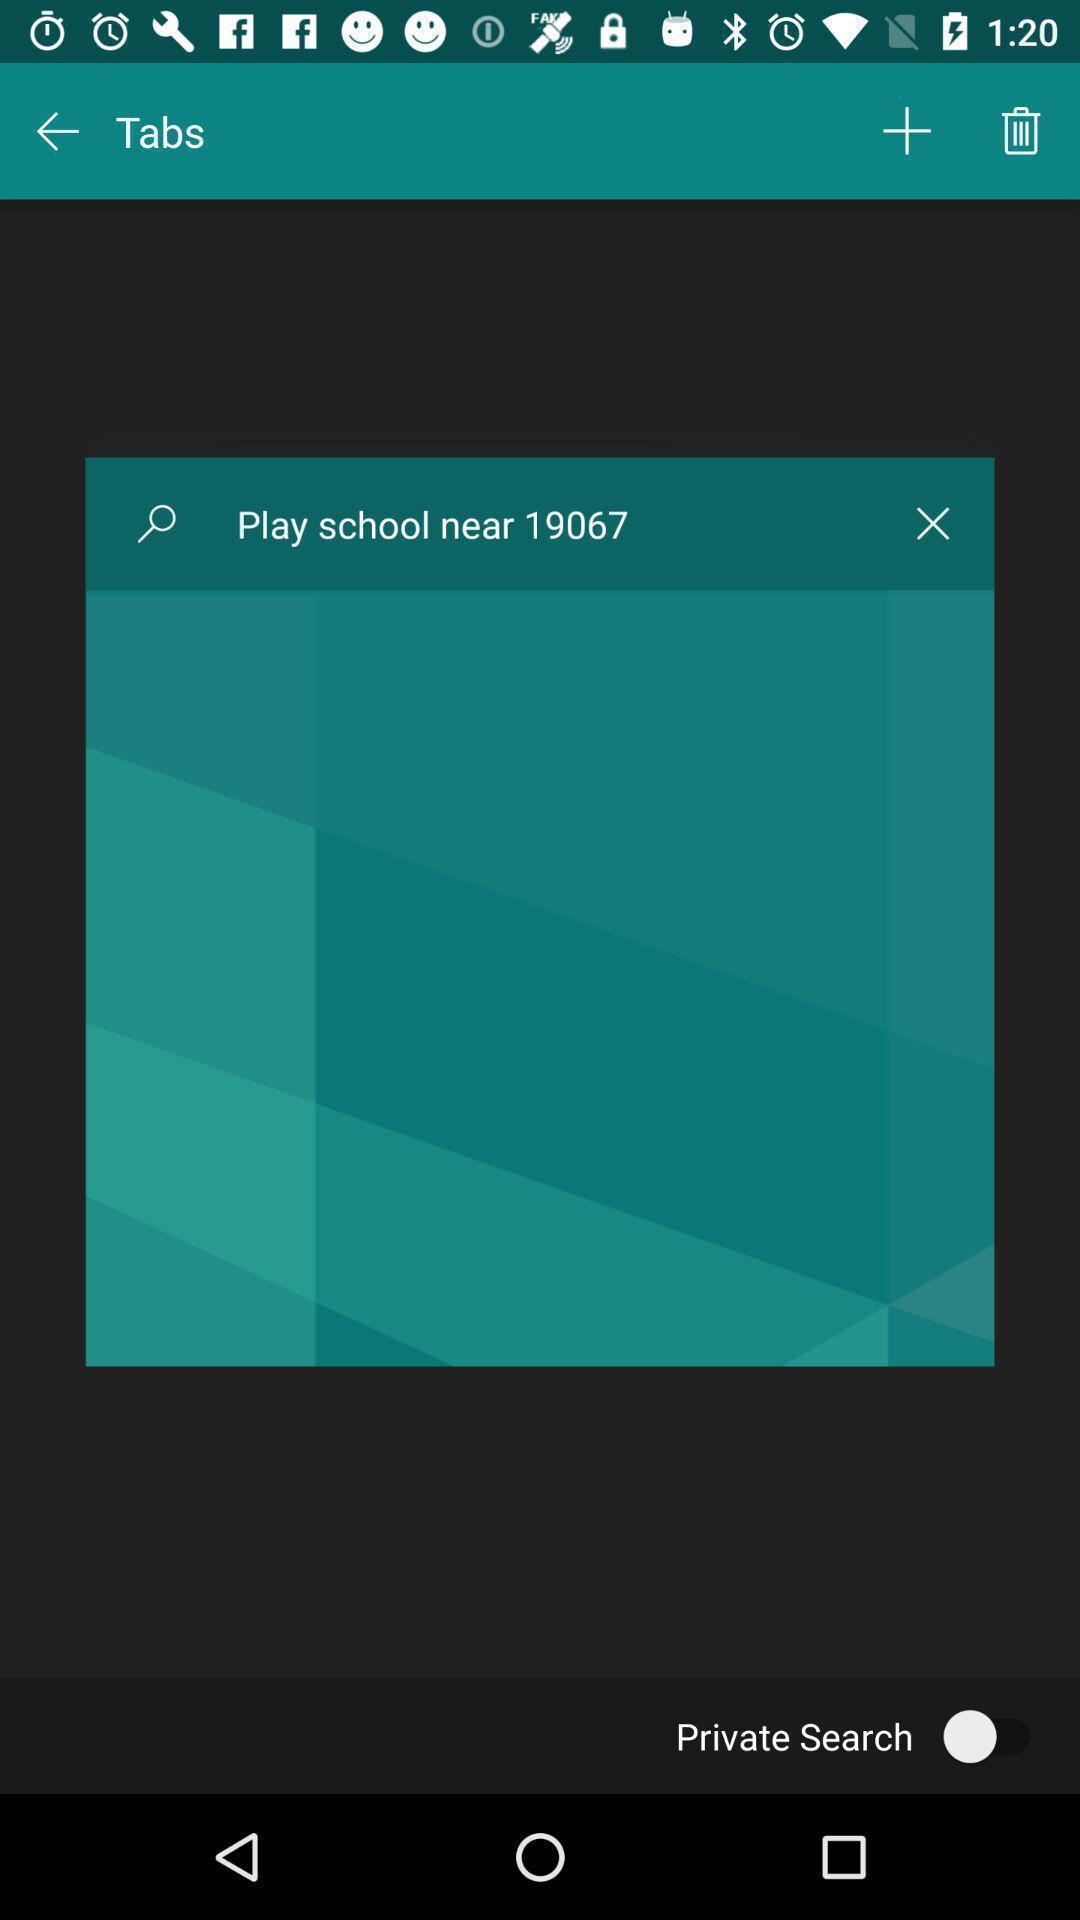Give me a narrative description of this picture. Pop-up showing near by play school. 